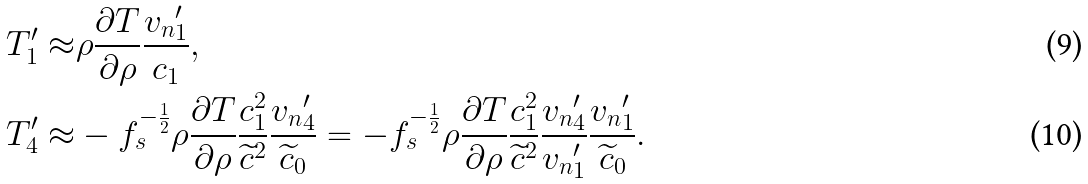Convert formula to latex. <formula><loc_0><loc_0><loc_500><loc_500>T ^ { \prime } _ { 1 } \approx & \rho \frac { \partial T } { \partial \rho } \frac { { v _ { n } } _ { 1 } ^ { \prime } } { c _ { 1 } } , \\ T ^ { \prime } _ { 4 } \approx & - f _ { s } ^ { - \frac { 1 } { 2 } } \rho \frac { \partial T } { \partial \rho } \frac { c _ { 1 } ^ { 2 } } { \widetilde { c } ^ { 2 } } \frac { { v _ { n } } _ { 4 } ^ { \prime } } { \widetilde { c } _ { 0 } } = - f _ { s } ^ { - \frac { 1 } { 2 } } \rho \frac { \partial T } { \partial \rho } \frac { c _ { 1 } ^ { 2 } } { \widetilde { c } ^ { 2 } } \frac { { v _ { n } } _ { 4 } ^ { \prime } } { { v _ { n } } _ { 1 } ^ { \prime } } \frac { { v _ { n } } _ { 1 } ^ { \prime } } { \widetilde { c } _ { 0 } } .</formula> 